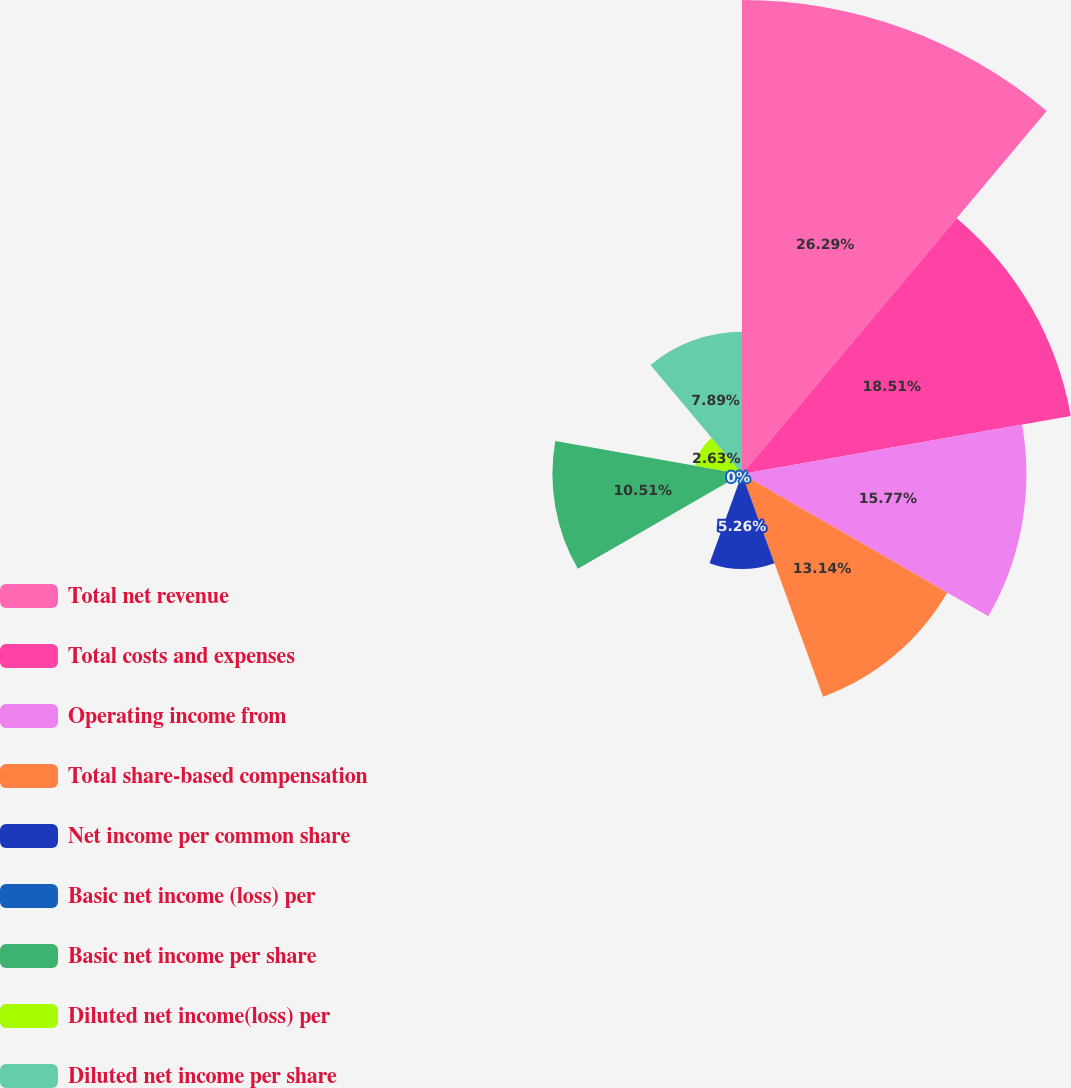Convert chart. <chart><loc_0><loc_0><loc_500><loc_500><pie_chart><fcel>Total net revenue<fcel>Total costs and expenses<fcel>Operating income from<fcel>Total share-based compensation<fcel>Net income per common share<fcel>Basic net income (loss) per<fcel>Basic net income per share<fcel>Diluted net income(loss) per<fcel>Diluted net income per share<nl><fcel>26.28%<fcel>18.51%<fcel>15.77%<fcel>13.14%<fcel>5.26%<fcel>0.0%<fcel>10.51%<fcel>2.63%<fcel>7.89%<nl></chart> 